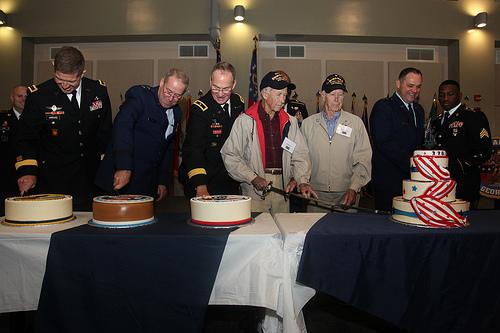Question: what does the cake on the right represent?
Choices:
A. A Birthday.
B. The American flag.
C. A Wedding.
D. A delicious snack.
Answer with the letter. Answer: B Question: what are on the tables?
Choices:
A. Cookies.
B. Cake.
C. Ice Cream.
D. Candy.
Answer with the letter. Answer: B Question: who are these men?
Choices:
A. Policemen.
B. Firemen.
C. Veterans.
D. Coast Guard.
Answer with the letter. Answer: C Question: what are the men doing?
Choices:
A. Cutting cakes.
B. Cutting bread.
C. Cutting pizza.
D. Cutting sandwiches.
Answer with the letter. Answer: A Question: how is the is the man in the middle cutting the cake?
Choices:
A. With a knife.
B. With a spatula.
C. With a pizza cutter.
D. With a sword.
Answer with the letter. Answer: D Question: what color are the table cloths?
Choices:
A. Blue and white.
B. Green.
C. Red.
D. Tan.
Answer with the letter. Answer: A 